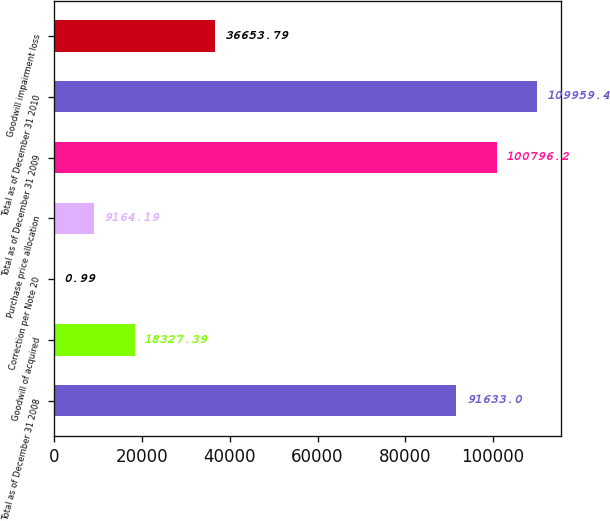Convert chart. <chart><loc_0><loc_0><loc_500><loc_500><bar_chart><fcel>Total as of December 31 2008<fcel>Goodwill of acquired<fcel>Correction per Note 20<fcel>Purchase price allocation<fcel>Total as of December 31 2009<fcel>Total as of December 31 2010<fcel>Goodwill impairment loss<nl><fcel>91633<fcel>18327.4<fcel>0.99<fcel>9164.19<fcel>100796<fcel>109959<fcel>36653.8<nl></chart> 